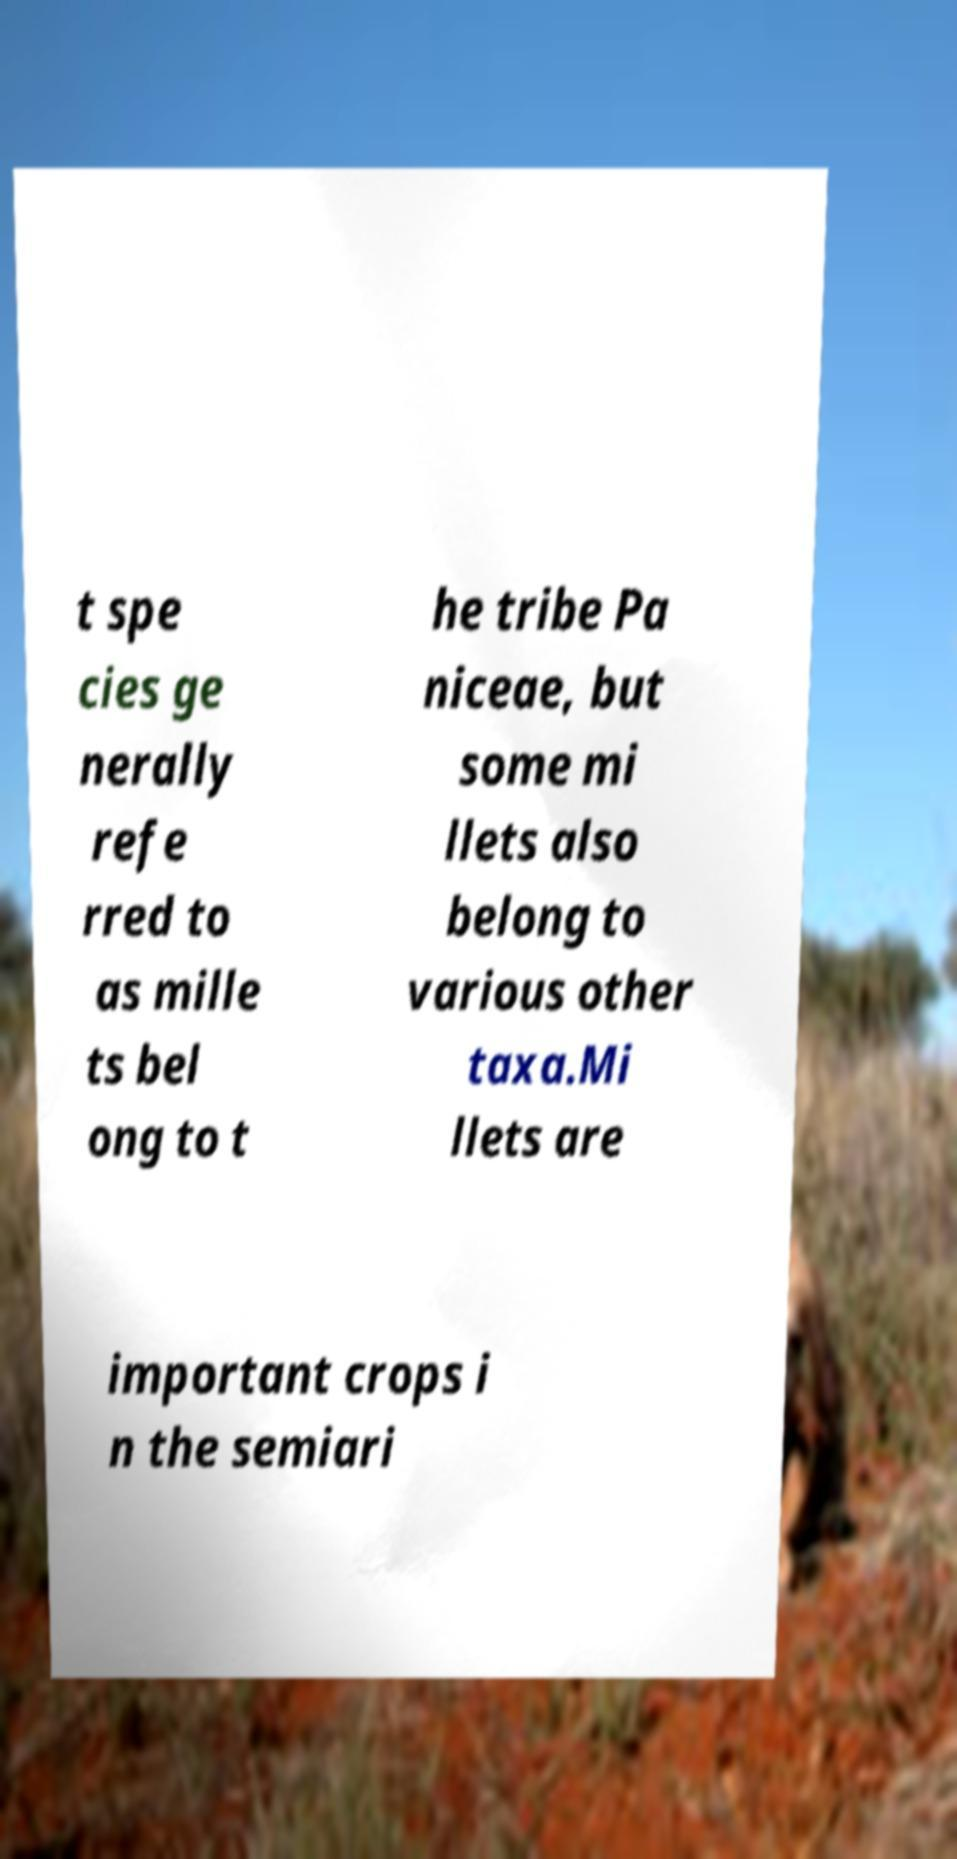I need the written content from this picture converted into text. Can you do that? t spe cies ge nerally refe rred to as mille ts bel ong to t he tribe Pa niceae, but some mi llets also belong to various other taxa.Mi llets are important crops i n the semiari 